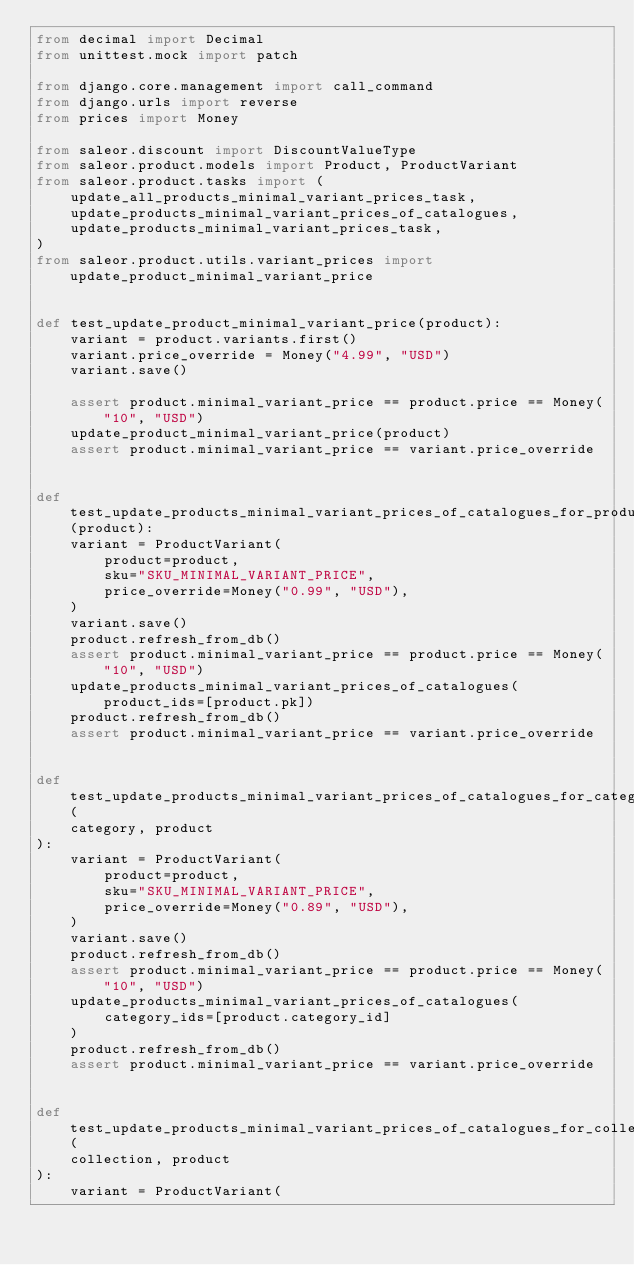Convert code to text. <code><loc_0><loc_0><loc_500><loc_500><_Python_>from decimal import Decimal
from unittest.mock import patch

from django.core.management import call_command
from django.urls import reverse
from prices import Money

from saleor.discount import DiscountValueType
from saleor.product.models import Product, ProductVariant
from saleor.product.tasks import (
    update_all_products_minimal_variant_prices_task,
    update_products_minimal_variant_prices_of_catalogues,
    update_products_minimal_variant_prices_task,
)
from saleor.product.utils.variant_prices import update_product_minimal_variant_price


def test_update_product_minimal_variant_price(product):
    variant = product.variants.first()
    variant.price_override = Money("4.99", "USD")
    variant.save()

    assert product.minimal_variant_price == product.price == Money("10", "USD")
    update_product_minimal_variant_price(product)
    assert product.minimal_variant_price == variant.price_override


def test_update_products_minimal_variant_prices_of_catalogues_for_product(product):
    variant = ProductVariant(
        product=product,
        sku="SKU_MINIMAL_VARIANT_PRICE",
        price_override=Money("0.99", "USD"),
    )
    variant.save()
    product.refresh_from_db()
    assert product.minimal_variant_price == product.price == Money("10", "USD")
    update_products_minimal_variant_prices_of_catalogues(product_ids=[product.pk])
    product.refresh_from_db()
    assert product.minimal_variant_price == variant.price_override


def test_update_products_minimal_variant_prices_of_catalogues_for_category(
    category, product
):
    variant = ProductVariant(
        product=product,
        sku="SKU_MINIMAL_VARIANT_PRICE",
        price_override=Money("0.89", "USD"),
    )
    variant.save()
    product.refresh_from_db()
    assert product.minimal_variant_price == product.price == Money("10", "USD")
    update_products_minimal_variant_prices_of_catalogues(
        category_ids=[product.category_id]
    )
    product.refresh_from_db()
    assert product.minimal_variant_price == variant.price_override


def test_update_products_minimal_variant_prices_of_catalogues_for_collection(
    collection, product
):
    variant = ProductVariant(</code> 